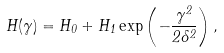<formula> <loc_0><loc_0><loc_500><loc_500>H ( \gamma ) = H _ { 0 } + H _ { 1 } \exp \left ( - \frac { \gamma ^ { 2 } } { 2 \delta ^ { 2 } } \right ) ,</formula> 